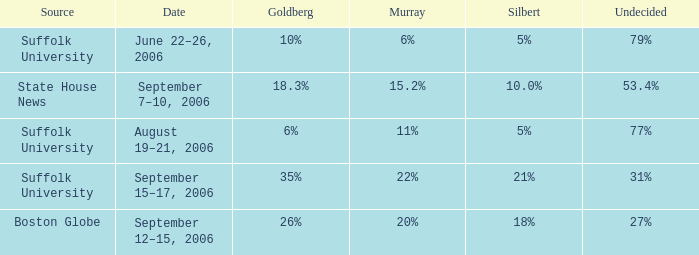What is the date of the poll with Goldberg at 26%? September 12–15, 2006. 